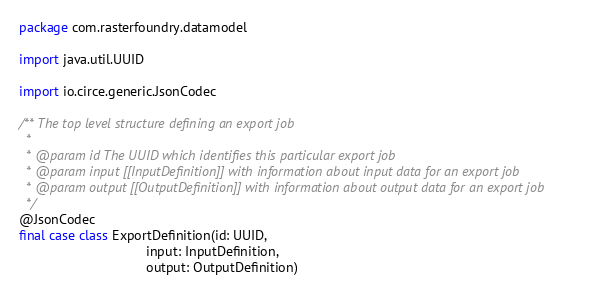<code> <loc_0><loc_0><loc_500><loc_500><_Scala_>package com.rasterfoundry.datamodel

import java.util.UUID

import io.circe.generic.JsonCodec

/** The top level structure defining an export job
  *
  * @param id The UUID which identifies this particular export job
  * @param input [[InputDefinition]] with information about input data for an export job
  * @param output [[OutputDefinition]] with information about output data for an export job
  */
@JsonCodec
final case class ExportDefinition(id: UUID,
                                  input: InputDefinition,
                                  output: OutputDefinition)
</code> 